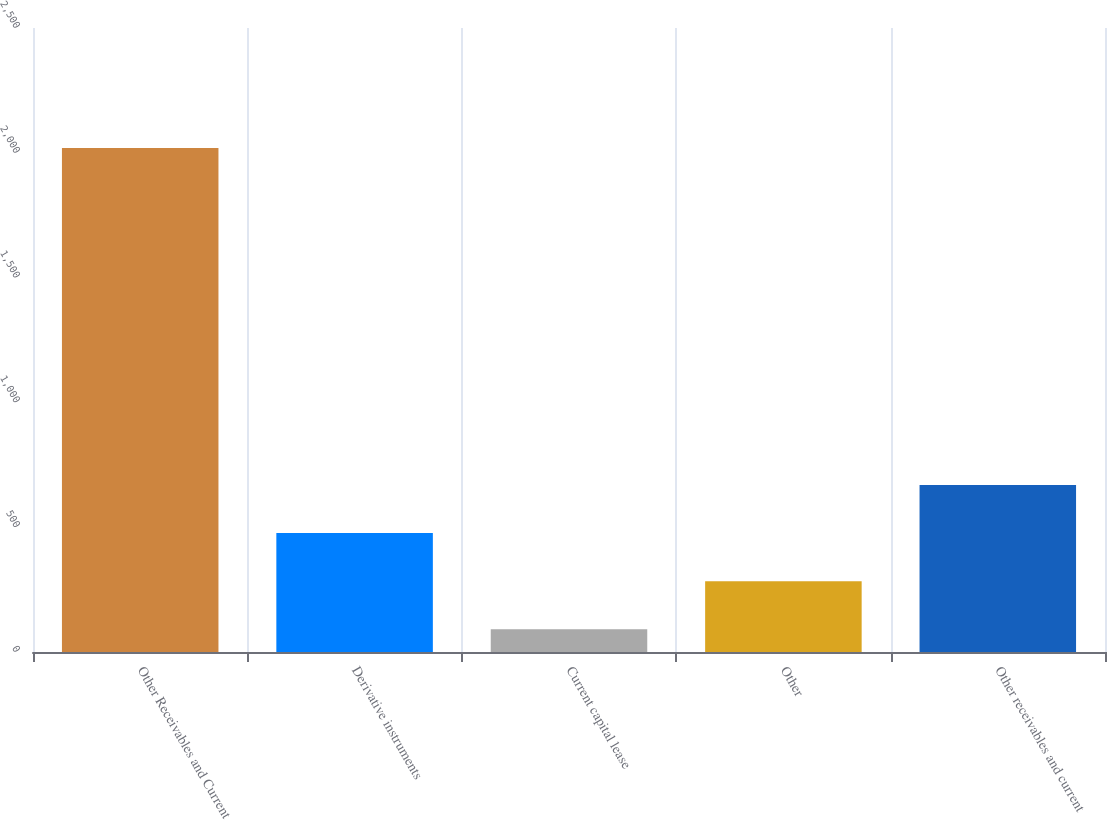Convert chart. <chart><loc_0><loc_0><loc_500><loc_500><bar_chart><fcel>Other Receivables and Current<fcel>Derivative instruments<fcel>Current capital lease<fcel>Other<fcel>Other receivables and current<nl><fcel>2019<fcel>476.52<fcel>90.9<fcel>283.71<fcel>669.33<nl></chart> 